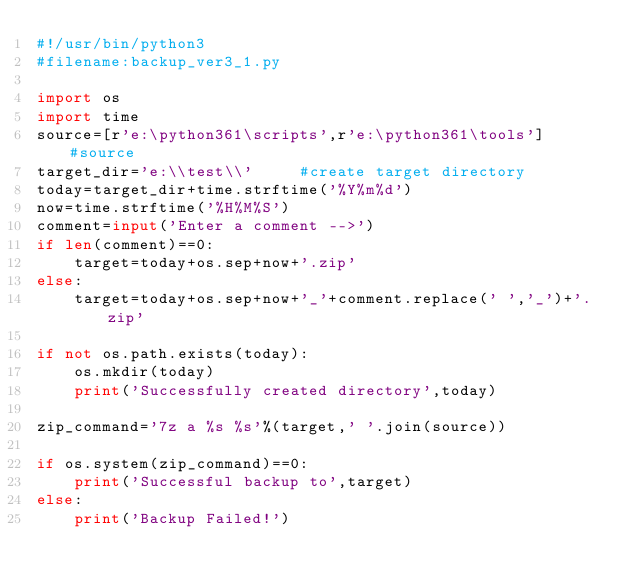<code> <loc_0><loc_0><loc_500><loc_500><_Python_>#!/usr/bin/python3
#filename:backup_ver3_1.py

import os
import time
source=[r'e:\python361\scripts',r'e:\python361\tools']      #source
target_dir='e:\\test\\'     #create target directory
today=target_dir+time.strftime('%Y%m%d')
now=time.strftime('%H%M%S')
comment=input('Enter a comment -->')
if len(comment)==0:
    target=today+os.sep+now+'.zip'
else:
    target=today+os.sep+now+'_'+comment.replace(' ','_')+'.zip'

if not os.path.exists(today):
    os.mkdir(today)
    print('Successfully created directory',today)

zip_command='7z a %s %s'%(target,' '.join(source))

if os.system(zip_command)==0:
    print('Successful backup to',target)
else:
    print('Backup Failed!')
</code> 